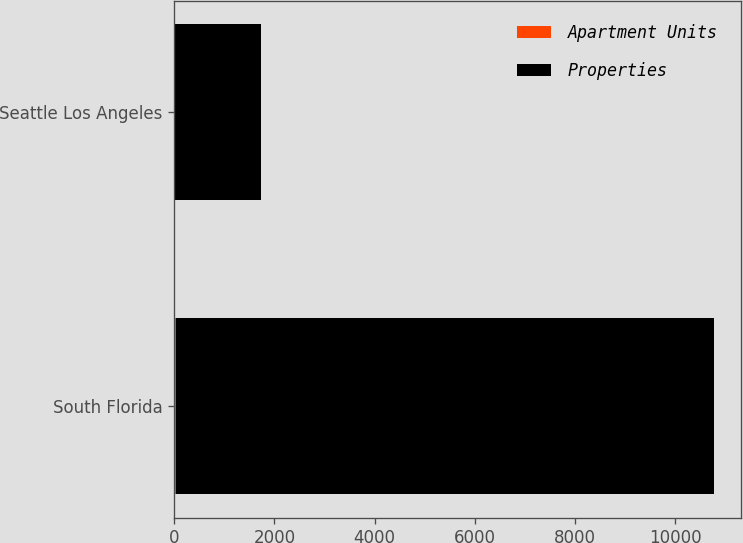Convert chart. <chart><loc_0><loc_0><loc_500><loc_500><stacked_bar_chart><ecel><fcel>South Florida<fcel>Seattle Los Angeles<nl><fcel>Apartment Units<fcel>33<fcel>8<nl><fcel>Properties<fcel>10742<fcel>1721<nl></chart> 